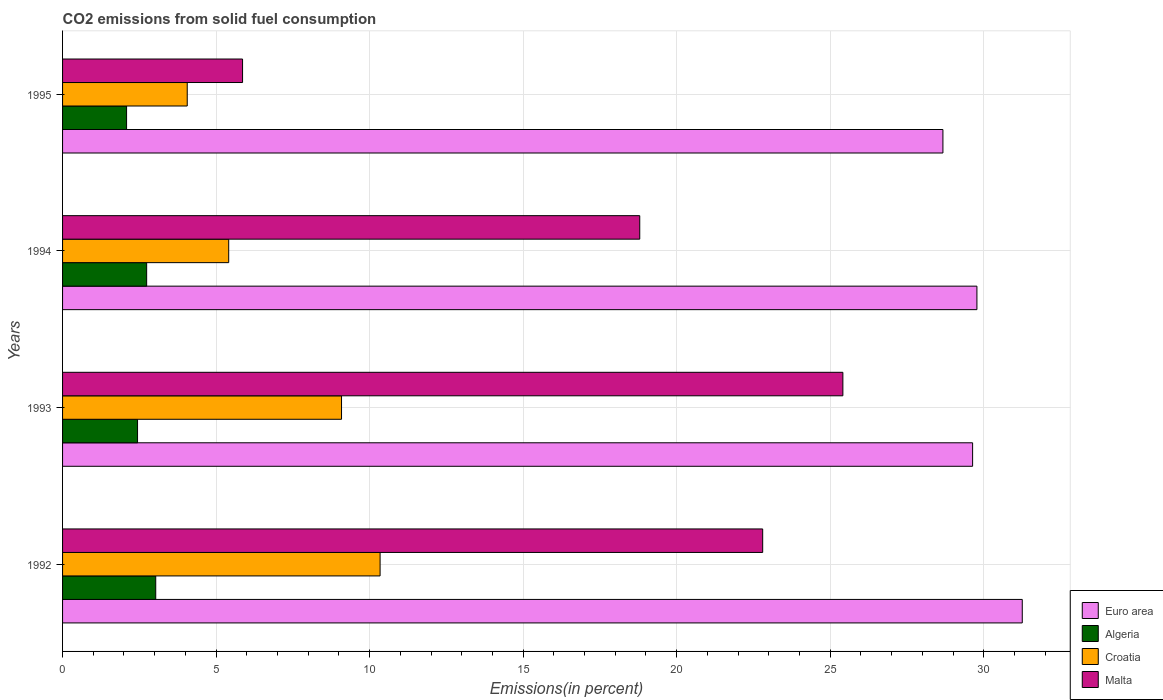How many groups of bars are there?
Ensure brevity in your answer.  4. Are the number of bars per tick equal to the number of legend labels?
Your answer should be compact. Yes. Are the number of bars on each tick of the Y-axis equal?
Your response must be concise. Yes. How many bars are there on the 2nd tick from the top?
Your answer should be compact. 4. What is the label of the 3rd group of bars from the top?
Keep it short and to the point. 1993. In how many cases, is the number of bars for a given year not equal to the number of legend labels?
Your answer should be very brief. 0. What is the total CO2 emitted in Malta in 1995?
Give a very brief answer. 5.86. Across all years, what is the maximum total CO2 emitted in Algeria?
Offer a terse response. 3.03. Across all years, what is the minimum total CO2 emitted in Euro area?
Give a very brief answer. 28.67. In which year was the total CO2 emitted in Algeria minimum?
Offer a very short reply. 1995. What is the total total CO2 emitted in Euro area in the graph?
Give a very brief answer. 119.34. What is the difference between the total CO2 emitted in Croatia in 1992 and that in 1994?
Offer a terse response. 4.93. What is the difference between the total CO2 emitted in Algeria in 1992 and the total CO2 emitted in Euro area in 1995?
Ensure brevity in your answer.  -25.64. What is the average total CO2 emitted in Croatia per year?
Provide a succinct answer. 7.22. In the year 1994, what is the difference between the total CO2 emitted in Malta and total CO2 emitted in Algeria?
Ensure brevity in your answer.  16.06. In how many years, is the total CO2 emitted in Croatia greater than 29 %?
Offer a terse response. 0. What is the ratio of the total CO2 emitted in Euro area in 1992 to that in 1994?
Your response must be concise. 1.05. What is the difference between the highest and the second highest total CO2 emitted in Algeria?
Offer a terse response. 0.3. What is the difference between the highest and the lowest total CO2 emitted in Malta?
Make the answer very short. 19.55. In how many years, is the total CO2 emitted in Euro area greater than the average total CO2 emitted in Euro area taken over all years?
Ensure brevity in your answer.  1. What does the 1st bar from the top in 1995 represents?
Give a very brief answer. Malta. What does the 2nd bar from the bottom in 1993 represents?
Provide a succinct answer. Algeria. Is it the case that in every year, the sum of the total CO2 emitted in Euro area and total CO2 emitted in Algeria is greater than the total CO2 emitted in Malta?
Offer a terse response. Yes. Are all the bars in the graph horizontal?
Give a very brief answer. Yes. How many years are there in the graph?
Your answer should be compact. 4. Are the values on the major ticks of X-axis written in scientific E-notation?
Make the answer very short. No. Does the graph contain any zero values?
Provide a succinct answer. No. Does the graph contain grids?
Keep it short and to the point. Yes. Where does the legend appear in the graph?
Provide a succinct answer. Bottom right. How many legend labels are there?
Make the answer very short. 4. How are the legend labels stacked?
Offer a very short reply. Vertical. What is the title of the graph?
Make the answer very short. CO2 emissions from solid fuel consumption. What is the label or title of the X-axis?
Ensure brevity in your answer.  Emissions(in percent). What is the Emissions(in percent) of Euro area in 1992?
Ensure brevity in your answer.  31.25. What is the Emissions(in percent) of Algeria in 1992?
Keep it short and to the point. 3.03. What is the Emissions(in percent) of Croatia in 1992?
Offer a very short reply. 10.34. What is the Emissions(in percent) in Malta in 1992?
Your response must be concise. 22.8. What is the Emissions(in percent) of Euro area in 1993?
Your answer should be very brief. 29.64. What is the Emissions(in percent) of Algeria in 1993?
Give a very brief answer. 2.44. What is the Emissions(in percent) of Croatia in 1993?
Give a very brief answer. 9.08. What is the Emissions(in percent) of Malta in 1993?
Ensure brevity in your answer.  25.41. What is the Emissions(in percent) in Euro area in 1994?
Provide a short and direct response. 29.78. What is the Emissions(in percent) of Algeria in 1994?
Your answer should be very brief. 2.74. What is the Emissions(in percent) in Croatia in 1994?
Your answer should be compact. 5.41. What is the Emissions(in percent) in Malta in 1994?
Your response must be concise. 18.8. What is the Emissions(in percent) in Euro area in 1995?
Your response must be concise. 28.67. What is the Emissions(in percent) of Algeria in 1995?
Your answer should be very brief. 2.08. What is the Emissions(in percent) in Croatia in 1995?
Your response must be concise. 4.06. What is the Emissions(in percent) of Malta in 1995?
Your answer should be compact. 5.86. Across all years, what is the maximum Emissions(in percent) in Euro area?
Your answer should be very brief. 31.25. Across all years, what is the maximum Emissions(in percent) in Algeria?
Offer a terse response. 3.03. Across all years, what is the maximum Emissions(in percent) in Croatia?
Ensure brevity in your answer.  10.34. Across all years, what is the maximum Emissions(in percent) in Malta?
Your answer should be very brief. 25.41. Across all years, what is the minimum Emissions(in percent) in Euro area?
Keep it short and to the point. 28.67. Across all years, what is the minimum Emissions(in percent) of Algeria?
Offer a terse response. 2.08. Across all years, what is the minimum Emissions(in percent) in Croatia?
Your response must be concise. 4.06. Across all years, what is the minimum Emissions(in percent) in Malta?
Your answer should be very brief. 5.86. What is the total Emissions(in percent) of Euro area in the graph?
Give a very brief answer. 119.34. What is the total Emissions(in percent) of Algeria in the graph?
Keep it short and to the point. 10.3. What is the total Emissions(in percent) in Croatia in the graph?
Offer a terse response. 28.9. What is the total Emissions(in percent) in Malta in the graph?
Keep it short and to the point. 72.87. What is the difference between the Emissions(in percent) in Euro area in 1992 and that in 1993?
Offer a terse response. 1.62. What is the difference between the Emissions(in percent) of Algeria in 1992 and that in 1993?
Your answer should be very brief. 0.59. What is the difference between the Emissions(in percent) of Croatia in 1992 and that in 1993?
Your response must be concise. 1.26. What is the difference between the Emissions(in percent) in Malta in 1992 and that in 1993?
Give a very brief answer. -2.61. What is the difference between the Emissions(in percent) of Euro area in 1992 and that in 1994?
Offer a very short reply. 1.48. What is the difference between the Emissions(in percent) of Algeria in 1992 and that in 1994?
Ensure brevity in your answer.  0.3. What is the difference between the Emissions(in percent) of Croatia in 1992 and that in 1994?
Offer a very short reply. 4.93. What is the difference between the Emissions(in percent) of Malta in 1992 and that in 1994?
Your answer should be very brief. 4. What is the difference between the Emissions(in percent) in Euro area in 1992 and that in 1995?
Make the answer very short. 2.58. What is the difference between the Emissions(in percent) of Algeria in 1992 and that in 1995?
Your answer should be very brief. 0.95. What is the difference between the Emissions(in percent) of Croatia in 1992 and that in 1995?
Offer a very short reply. 6.28. What is the difference between the Emissions(in percent) in Malta in 1992 and that in 1995?
Give a very brief answer. 16.94. What is the difference between the Emissions(in percent) in Euro area in 1993 and that in 1994?
Provide a succinct answer. -0.14. What is the difference between the Emissions(in percent) of Algeria in 1993 and that in 1994?
Offer a terse response. -0.3. What is the difference between the Emissions(in percent) in Croatia in 1993 and that in 1994?
Offer a terse response. 3.67. What is the difference between the Emissions(in percent) in Malta in 1993 and that in 1994?
Provide a short and direct response. 6.62. What is the difference between the Emissions(in percent) in Euro area in 1993 and that in 1995?
Provide a succinct answer. 0.97. What is the difference between the Emissions(in percent) in Algeria in 1993 and that in 1995?
Your answer should be very brief. 0.36. What is the difference between the Emissions(in percent) of Croatia in 1993 and that in 1995?
Offer a terse response. 5.02. What is the difference between the Emissions(in percent) of Malta in 1993 and that in 1995?
Keep it short and to the point. 19.55. What is the difference between the Emissions(in percent) of Euro area in 1994 and that in 1995?
Your answer should be very brief. 1.11. What is the difference between the Emissions(in percent) in Algeria in 1994 and that in 1995?
Your response must be concise. 0.65. What is the difference between the Emissions(in percent) in Croatia in 1994 and that in 1995?
Your answer should be very brief. 1.35. What is the difference between the Emissions(in percent) in Malta in 1994 and that in 1995?
Provide a succinct answer. 12.93. What is the difference between the Emissions(in percent) of Euro area in 1992 and the Emissions(in percent) of Algeria in 1993?
Keep it short and to the point. 28.81. What is the difference between the Emissions(in percent) of Euro area in 1992 and the Emissions(in percent) of Croatia in 1993?
Your answer should be compact. 22.17. What is the difference between the Emissions(in percent) in Euro area in 1992 and the Emissions(in percent) in Malta in 1993?
Your answer should be compact. 5.84. What is the difference between the Emissions(in percent) of Algeria in 1992 and the Emissions(in percent) of Croatia in 1993?
Keep it short and to the point. -6.05. What is the difference between the Emissions(in percent) in Algeria in 1992 and the Emissions(in percent) in Malta in 1993?
Keep it short and to the point. -22.38. What is the difference between the Emissions(in percent) in Croatia in 1992 and the Emissions(in percent) in Malta in 1993?
Give a very brief answer. -15.07. What is the difference between the Emissions(in percent) of Euro area in 1992 and the Emissions(in percent) of Algeria in 1994?
Offer a terse response. 28.52. What is the difference between the Emissions(in percent) of Euro area in 1992 and the Emissions(in percent) of Croatia in 1994?
Provide a succinct answer. 25.84. What is the difference between the Emissions(in percent) of Euro area in 1992 and the Emissions(in percent) of Malta in 1994?
Provide a succinct answer. 12.46. What is the difference between the Emissions(in percent) in Algeria in 1992 and the Emissions(in percent) in Croatia in 1994?
Ensure brevity in your answer.  -2.38. What is the difference between the Emissions(in percent) in Algeria in 1992 and the Emissions(in percent) in Malta in 1994?
Your response must be concise. -15.76. What is the difference between the Emissions(in percent) in Croatia in 1992 and the Emissions(in percent) in Malta in 1994?
Offer a very short reply. -8.46. What is the difference between the Emissions(in percent) of Euro area in 1992 and the Emissions(in percent) of Algeria in 1995?
Provide a succinct answer. 29.17. What is the difference between the Emissions(in percent) of Euro area in 1992 and the Emissions(in percent) of Croatia in 1995?
Offer a very short reply. 27.19. What is the difference between the Emissions(in percent) of Euro area in 1992 and the Emissions(in percent) of Malta in 1995?
Provide a short and direct response. 25.39. What is the difference between the Emissions(in percent) of Algeria in 1992 and the Emissions(in percent) of Croatia in 1995?
Offer a terse response. -1.03. What is the difference between the Emissions(in percent) in Algeria in 1992 and the Emissions(in percent) in Malta in 1995?
Your answer should be very brief. -2.83. What is the difference between the Emissions(in percent) in Croatia in 1992 and the Emissions(in percent) in Malta in 1995?
Ensure brevity in your answer.  4.48. What is the difference between the Emissions(in percent) of Euro area in 1993 and the Emissions(in percent) of Algeria in 1994?
Provide a succinct answer. 26.9. What is the difference between the Emissions(in percent) in Euro area in 1993 and the Emissions(in percent) in Croatia in 1994?
Ensure brevity in your answer.  24.23. What is the difference between the Emissions(in percent) of Euro area in 1993 and the Emissions(in percent) of Malta in 1994?
Make the answer very short. 10.84. What is the difference between the Emissions(in percent) in Algeria in 1993 and the Emissions(in percent) in Croatia in 1994?
Your answer should be very brief. -2.97. What is the difference between the Emissions(in percent) in Algeria in 1993 and the Emissions(in percent) in Malta in 1994?
Make the answer very short. -16.36. What is the difference between the Emissions(in percent) of Croatia in 1993 and the Emissions(in percent) of Malta in 1994?
Keep it short and to the point. -9.71. What is the difference between the Emissions(in percent) of Euro area in 1993 and the Emissions(in percent) of Algeria in 1995?
Keep it short and to the point. 27.55. What is the difference between the Emissions(in percent) in Euro area in 1993 and the Emissions(in percent) in Croatia in 1995?
Provide a short and direct response. 25.58. What is the difference between the Emissions(in percent) of Euro area in 1993 and the Emissions(in percent) of Malta in 1995?
Offer a terse response. 23.78. What is the difference between the Emissions(in percent) in Algeria in 1993 and the Emissions(in percent) in Croatia in 1995?
Ensure brevity in your answer.  -1.62. What is the difference between the Emissions(in percent) of Algeria in 1993 and the Emissions(in percent) of Malta in 1995?
Ensure brevity in your answer.  -3.42. What is the difference between the Emissions(in percent) in Croatia in 1993 and the Emissions(in percent) in Malta in 1995?
Your answer should be very brief. 3.22. What is the difference between the Emissions(in percent) of Euro area in 1994 and the Emissions(in percent) of Algeria in 1995?
Keep it short and to the point. 27.69. What is the difference between the Emissions(in percent) in Euro area in 1994 and the Emissions(in percent) in Croatia in 1995?
Keep it short and to the point. 25.72. What is the difference between the Emissions(in percent) of Euro area in 1994 and the Emissions(in percent) of Malta in 1995?
Give a very brief answer. 23.92. What is the difference between the Emissions(in percent) in Algeria in 1994 and the Emissions(in percent) in Croatia in 1995?
Offer a very short reply. -1.32. What is the difference between the Emissions(in percent) in Algeria in 1994 and the Emissions(in percent) in Malta in 1995?
Make the answer very short. -3.12. What is the difference between the Emissions(in percent) of Croatia in 1994 and the Emissions(in percent) of Malta in 1995?
Your answer should be compact. -0.45. What is the average Emissions(in percent) of Euro area per year?
Make the answer very short. 29.84. What is the average Emissions(in percent) in Algeria per year?
Provide a short and direct response. 2.57. What is the average Emissions(in percent) in Croatia per year?
Your response must be concise. 7.22. What is the average Emissions(in percent) of Malta per year?
Give a very brief answer. 18.22. In the year 1992, what is the difference between the Emissions(in percent) in Euro area and Emissions(in percent) in Algeria?
Ensure brevity in your answer.  28.22. In the year 1992, what is the difference between the Emissions(in percent) in Euro area and Emissions(in percent) in Croatia?
Provide a succinct answer. 20.91. In the year 1992, what is the difference between the Emissions(in percent) in Euro area and Emissions(in percent) in Malta?
Your answer should be very brief. 8.45. In the year 1992, what is the difference between the Emissions(in percent) of Algeria and Emissions(in percent) of Croatia?
Provide a short and direct response. -7.31. In the year 1992, what is the difference between the Emissions(in percent) in Algeria and Emissions(in percent) in Malta?
Give a very brief answer. -19.77. In the year 1992, what is the difference between the Emissions(in percent) of Croatia and Emissions(in percent) of Malta?
Provide a succinct answer. -12.46. In the year 1993, what is the difference between the Emissions(in percent) in Euro area and Emissions(in percent) in Algeria?
Make the answer very short. 27.2. In the year 1993, what is the difference between the Emissions(in percent) of Euro area and Emissions(in percent) of Croatia?
Your answer should be compact. 20.55. In the year 1993, what is the difference between the Emissions(in percent) in Euro area and Emissions(in percent) in Malta?
Ensure brevity in your answer.  4.23. In the year 1993, what is the difference between the Emissions(in percent) of Algeria and Emissions(in percent) of Croatia?
Ensure brevity in your answer.  -6.64. In the year 1993, what is the difference between the Emissions(in percent) in Algeria and Emissions(in percent) in Malta?
Provide a short and direct response. -22.97. In the year 1993, what is the difference between the Emissions(in percent) of Croatia and Emissions(in percent) of Malta?
Your answer should be compact. -16.33. In the year 1994, what is the difference between the Emissions(in percent) of Euro area and Emissions(in percent) of Algeria?
Offer a terse response. 27.04. In the year 1994, what is the difference between the Emissions(in percent) in Euro area and Emissions(in percent) in Croatia?
Provide a short and direct response. 24.37. In the year 1994, what is the difference between the Emissions(in percent) of Euro area and Emissions(in percent) of Malta?
Offer a very short reply. 10.98. In the year 1994, what is the difference between the Emissions(in percent) of Algeria and Emissions(in percent) of Croatia?
Your answer should be very brief. -2.67. In the year 1994, what is the difference between the Emissions(in percent) of Algeria and Emissions(in percent) of Malta?
Keep it short and to the point. -16.06. In the year 1994, what is the difference between the Emissions(in percent) of Croatia and Emissions(in percent) of Malta?
Your response must be concise. -13.39. In the year 1995, what is the difference between the Emissions(in percent) of Euro area and Emissions(in percent) of Algeria?
Offer a terse response. 26.59. In the year 1995, what is the difference between the Emissions(in percent) in Euro area and Emissions(in percent) in Croatia?
Provide a succinct answer. 24.61. In the year 1995, what is the difference between the Emissions(in percent) in Euro area and Emissions(in percent) in Malta?
Your answer should be very brief. 22.81. In the year 1995, what is the difference between the Emissions(in percent) of Algeria and Emissions(in percent) of Croatia?
Offer a very short reply. -1.98. In the year 1995, what is the difference between the Emissions(in percent) of Algeria and Emissions(in percent) of Malta?
Offer a very short reply. -3.78. In the year 1995, what is the difference between the Emissions(in percent) in Croatia and Emissions(in percent) in Malta?
Your answer should be very brief. -1.8. What is the ratio of the Emissions(in percent) in Euro area in 1992 to that in 1993?
Provide a short and direct response. 1.05. What is the ratio of the Emissions(in percent) of Algeria in 1992 to that in 1993?
Your answer should be compact. 1.24. What is the ratio of the Emissions(in percent) of Croatia in 1992 to that in 1993?
Ensure brevity in your answer.  1.14. What is the ratio of the Emissions(in percent) of Malta in 1992 to that in 1993?
Offer a terse response. 0.9. What is the ratio of the Emissions(in percent) of Euro area in 1992 to that in 1994?
Your answer should be compact. 1.05. What is the ratio of the Emissions(in percent) of Algeria in 1992 to that in 1994?
Your answer should be compact. 1.11. What is the ratio of the Emissions(in percent) in Croatia in 1992 to that in 1994?
Ensure brevity in your answer.  1.91. What is the ratio of the Emissions(in percent) in Malta in 1992 to that in 1994?
Ensure brevity in your answer.  1.21. What is the ratio of the Emissions(in percent) in Euro area in 1992 to that in 1995?
Ensure brevity in your answer.  1.09. What is the ratio of the Emissions(in percent) in Algeria in 1992 to that in 1995?
Offer a very short reply. 1.46. What is the ratio of the Emissions(in percent) in Croatia in 1992 to that in 1995?
Ensure brevity in your answer.  2.55. What is the ratio of the Emissions(in percent) of Malta in 1992 to that in 1995?
Provide a succinct answer. 3.89. What is the ratio of the Emissions(in percent) of Algeria in 1993 to that in 1994?
Ensure brevity in your answer.  0.89. What is the ratio of the Emissions(in percent) of Croatia in 1993 to that in 1994?
Make the answer very short. 1.68. What is the ratio of the Emissions(in percent) in Malta in 1993 to that in 1994?
Your response must be concise. 1.35. What is the ratio of the Emissions(in percent) of Euro area in 1993 to that in 1995?
Provide a succinct answer. 1.03. What is the ratio of the Emissions(in percent) in Algeria in 1993 to that in 1995?
Your answer should be compact. 1.17. What is the ratio of the Emissions(in percent) of Croatia in 1993 to that in 1995?
Ensure brevity in your answer.  2.24. What is the ratio of the Emissions(in percent) of Malta in 1993 to that in 1995?
Keep it short and to the point. 4.33. What is the ratio of the Emissions(in percent) in Euro area in 1994 to that in 1995?
Give a very brief answer. 1.04. What is the ratio of the Emissions(in percent) in Algeria in 1994 to that in 1995?
Your answer should be very brief. 1.31. What is the ratio of the Emissions(in percent) of Croatia in 1994 to that in 1995?
Your answer should be very brief. 1.33. What is the ratio of the Emissions(in percent) in Malta in 1994 to that in 1995?
Offer a very short reply. 3.21. What is the difference between the highest and the second highest Emissions(in percent) of Euro area?
Offer a very short reply. 1.48. What is the difference between the highest and the second highest Emissions(in percent) of Algeria?
Your answer should be compact. 0.3. What is the difference between the highest and the second highest Emissions(in percent) in Croatia?
Provide a succinct answer. 1.26. What is the difference between the highest and the second highest Emissions(in percent) of Malta?
Give a very brief answer. 2.61. What is the difference between the highest and the lowest Emissions(in percent) of Euro area?
Your answer should be very brief. 2.58. What is the difference between the highest and the lowest Emissions(in percent) in Algeria?
Provide a succinct answer. 0.95. What is the difference between the highest and the lowest Emissions(in percent) in Croatia?
Your response must be concise. 6.28. What is the difference between the highest and the lowest Emissions(in percent) in Malta?
Provide a succinct answer. 19.55. 